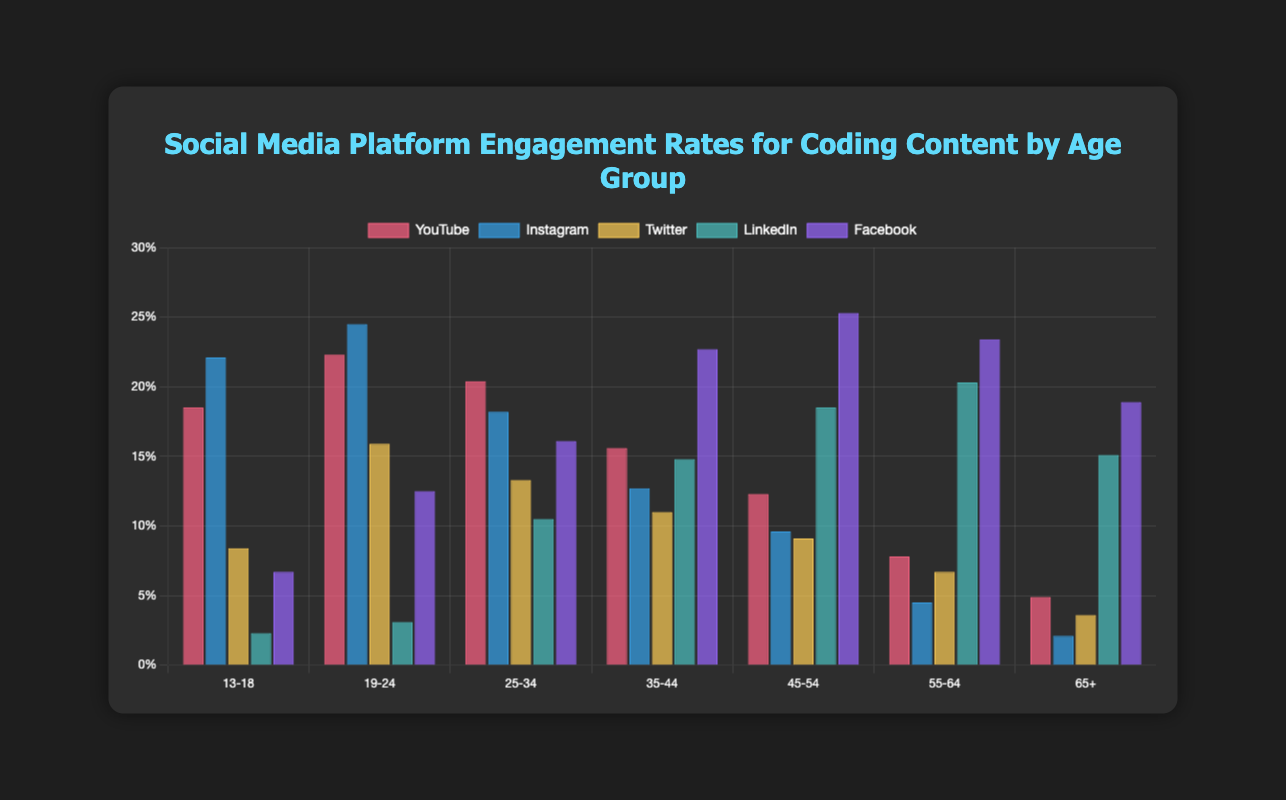Which age group shows the highest engagement rate on Instagram? Looking at the bar heights in each age group for Instagram, the highest bar is for the 19-24 age group at 24.5%.
Answer: 19-24 Between Facebook and LinkedIn, which platform shows higher engagement rates for the 45-54 age group? Comparing the bar heights of Facebook (25.3%) and LinkedIn (18.5%) for the 45-54 age group, Facebook has the higher engagement rate.
Answer: Facebook What is the total engagement rate for Twitter across all age groups? The sum of Twitter engagement rates across age groups is 8.4 + 15.9 + 13.3 + 11.0 + 9.1 + 6.7 + 3.6, which equals 68.0%.
Answer: 68.0% Which platform has the smallest engagement rate for the 13-18 age group and what is it? Among YouTube, Instagram, Twitter, LinkedIn, and Facebook, the smallest bar for the 13-18 age group is LinkedIn at 2.3%.
Answer: LinkedIn, 2.3% How does LinkedIn's engagement rate for the 25-34 age group compare with that for the 55-64 age group? The LinkedIn engagement rate for the 25-34 age group is 10.5% and for the 55-64 age group is 20.3%. The 55-64 age group has nearly double the engagement rate compared to the 25-34 age group.
Answer: 55-64 is higher What is the overall engagement trend on YouTube as age increases? Observing the bar heights for YouTube across age groups: 18.5% (13-18), 22.3% (19-24), 20.4% (25-34), 15.6% (35-44), 12.3% (45-54), 7.8% (55-64), 4.9% (65+), it's clear that engagement generally decreases as age increases.
Answer: Decreasing Which platform and age group has the highest engagement rate overall? Looking at the bars for all platforms and age groups, the highest is Instagram for the 19-24 age group at 24.5%.
Answer: Instagram, 19-24 What is the engagement difference between YouTube and Instagram for the 13-18 age group? For the 13-18 age group, YouTube's engagement is 18.5% and Instagram's engagement is 22.1%. The difference is 22.1 - 18.5 = 3.6%.
Answer: 3.6% Compare the engagement rates on Facebook and Twitter for the 35-44 age group. Which one is higher and by how much? For the 35-44 age group, Facebook's engagement rate is 22.7% and Twitter's is 11.0%. Facebook's rate is higher by 22.7 - 11.0 = 11.7%.
Answer: Facebook, by 11.7% Which age group has the smallest variation in engagement rates across all platforms, and what are the maximum and minimum engagement rates for that age group? The 13-18 age group has the engagement rates: 18.5% (YouTube), 22.1% (Instagram), 8.4% (Twitter), 2.3% (LinkedIn), 6.7% (Facebook). The maximum rate is 22.1% (Instagram) and the minimum rate is 2.3% (LinkedIn).
Answer: 13-18, max 22.1%, min 2.3% 